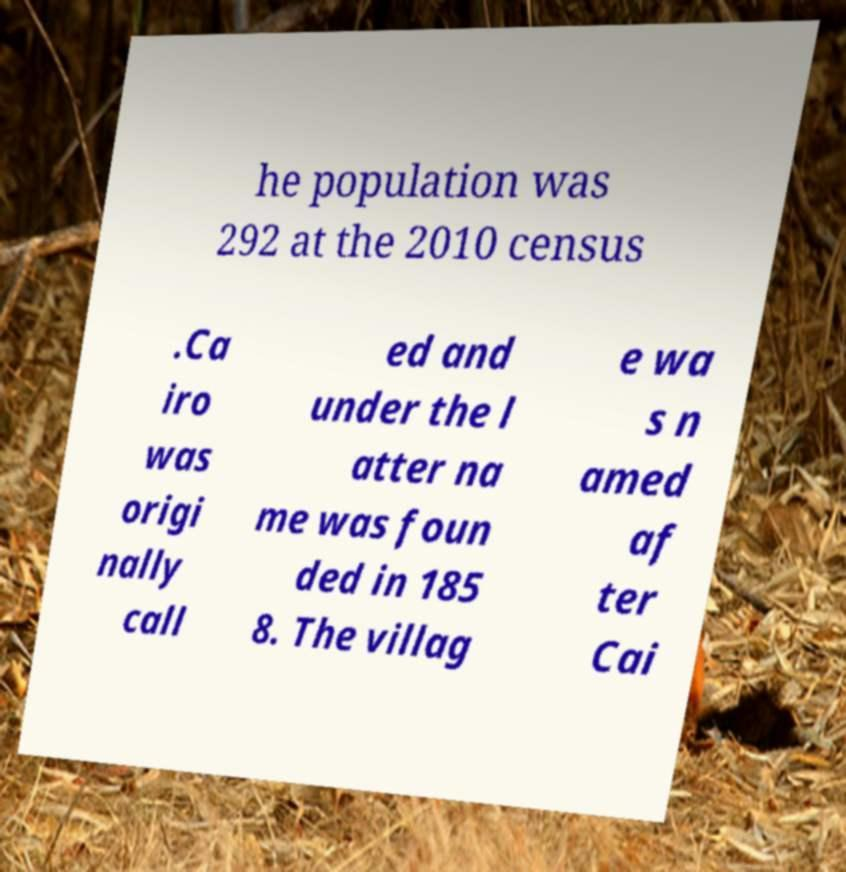I need the written content from this picture converted into text. Can you do that? he population was 292 at the 2010 census .Ca iro was origi nally call ed and under the l atter na me was foun ded in 185 8. The villag e wa s n amed af ter Cai 